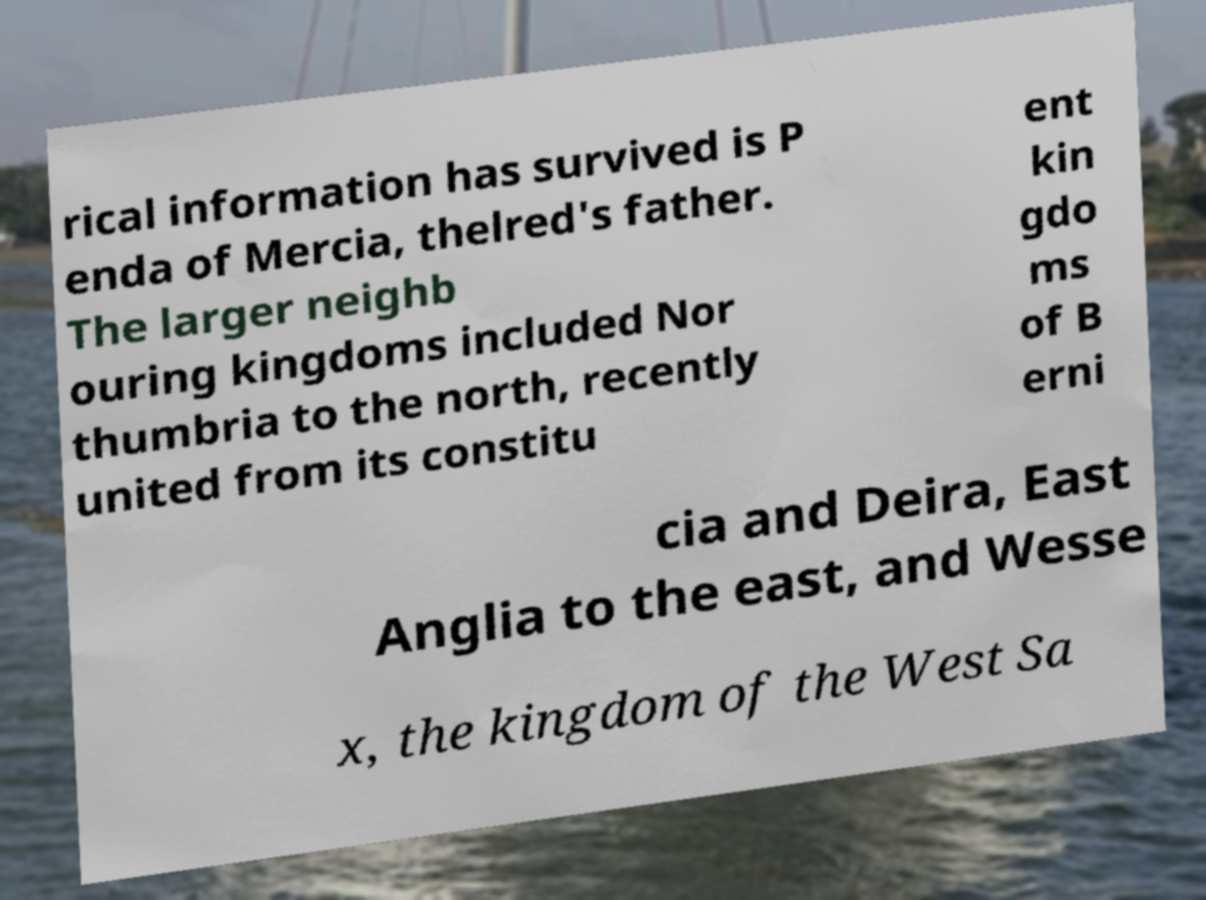There's text embedded in this image that I need extracted. Can you transcribe it verbatim? rical information has survived is P enda of Mercia, thelred's father. The larger neighb ouring kingdoms included Nor thumbria to the north, recently united from its constitu ent kin gdo ms of B erni cia and Deira, East Anglia to the east, and Wesse x, the kingdom of the West Sa 